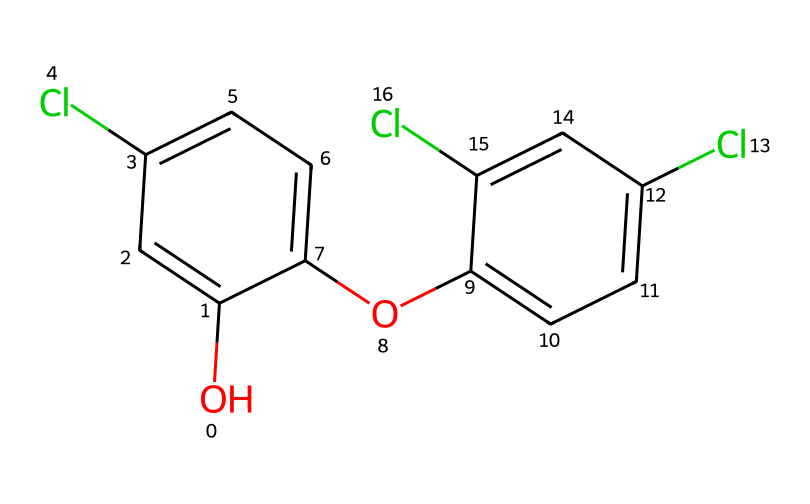What is the molecular formula of triclosan? To determine the molecular formula, count the number of each type of atom in the SMILES representation. In this case, there are 12 carbon (C) atoms, 8 hydrogen (H) atoms, 4 chlorine (Cl) atoms, and 2 oxygen (O) atoms. Therefore, the molecular formula is C12H8Cl4O2.
Answer: C12H8Cl4O2 How many rings does the structure of triclosan contain? Examining the structure from the SMILES, there are two distinct cyclic structures indicated by the 'c' notation which represents aromatic carbon atoms. Each cycle contributes to the overall stability and functionality of the molecule. Therefore, the structure has 2 rings.
Answer: 2 What types of substituents are present in this molecule? By analyzing the chemical structure, we note that there are chlorine (Cl) atoms and hydroxyl (OH) groups as substituents. Substituents like these can significantly affect both the physical properties and biological activity of the molecule. Therefore, the types of substituents are chloro and hydroxy.
Answer: chloro and hydroxy Are there any polar functional groups in triclosan? Observing the structure, the presence of the hydroxyl (OH) group indicates a polar functional group. Polar groups generally enhance the solubility and reactivity of the molecule with various substances. Therefore, there is a polar functional group (hydroxyl) in triclosan.
Answer: hydroxyl What is the possible impact of chlorine substituents on triclosan's antibacterial properties? Chlorine substituents can increase the compound's hydrophobic interactions and also enhance its reactivity with microorganisms. Therefore, the presence of chlorine atoms may positively impact triclosan's antibacterial efficacy.
Answer: increase efficacy What type of chemical is triclosan classified as? Triclosan is primarily classified as an antibacterial agent and a biocide. Its structure allows it to disrupt microbial membrane integrity and inhibit fatty acid synthesis. Therefore, triclosan is classified as an antibacterial agent.
Answer: antibacterial agent 